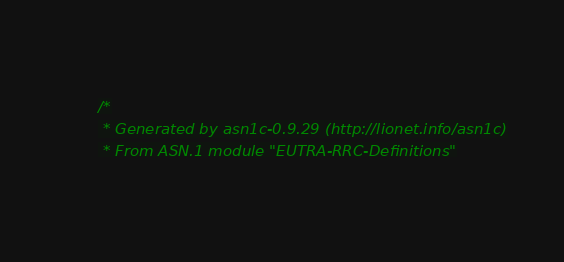<code> <loc_0><loc_0><loc_500><loc_500><_C_>/*
 * Generated by asn1c-0.9.29 (http://lionet.info/asn1c)
 * From ASN.1 module "EUTRA-RRC-Definitions"</code> 